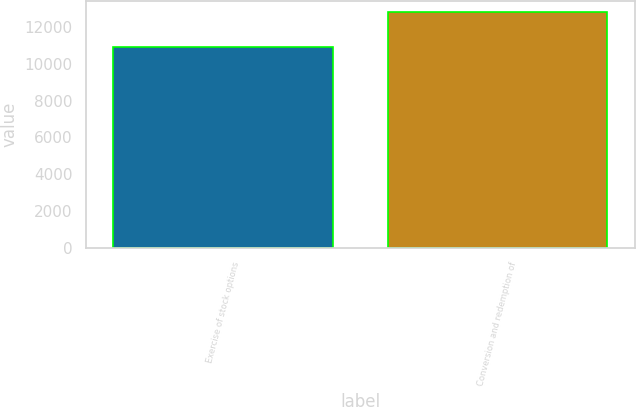<chart> <loc_0><loc_0><loc_500><loc_500><bar_chart><fcel>Exercise of stock options<fcel>Conversion and redemption of<nl><fcel>10947<fcel>12806<nl></chart> 